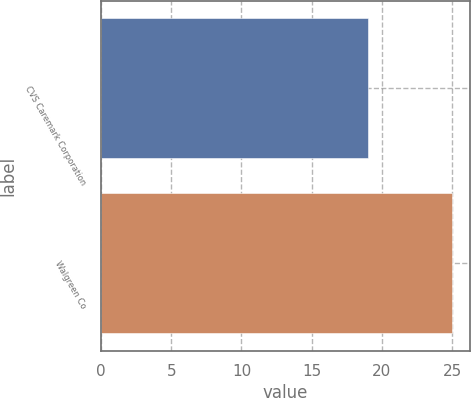Convert chart. <chart><loc_0><loc_0><loc_500><loc_500><bar_chart><fcel>CVS Caremark Corporation<fcel>Walgreen Co<nl><fcel>19<fcel>25<nl></chart> 